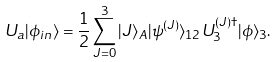<formula> <loc_0><loc_0><loc_500><loc_500>U _ { a } | \phi _ { i n } \rangle = \frac { 1 } { 2 } \sum _ { J = 0 } ^ { 3 } | J \rangle _ { A } | \psi ^ { ( J ) } \rangle _ { 1 2 } U _ { 3 } ^ { ( J ) \dag } | \phi \rangle _ { 3 } .</formula> 